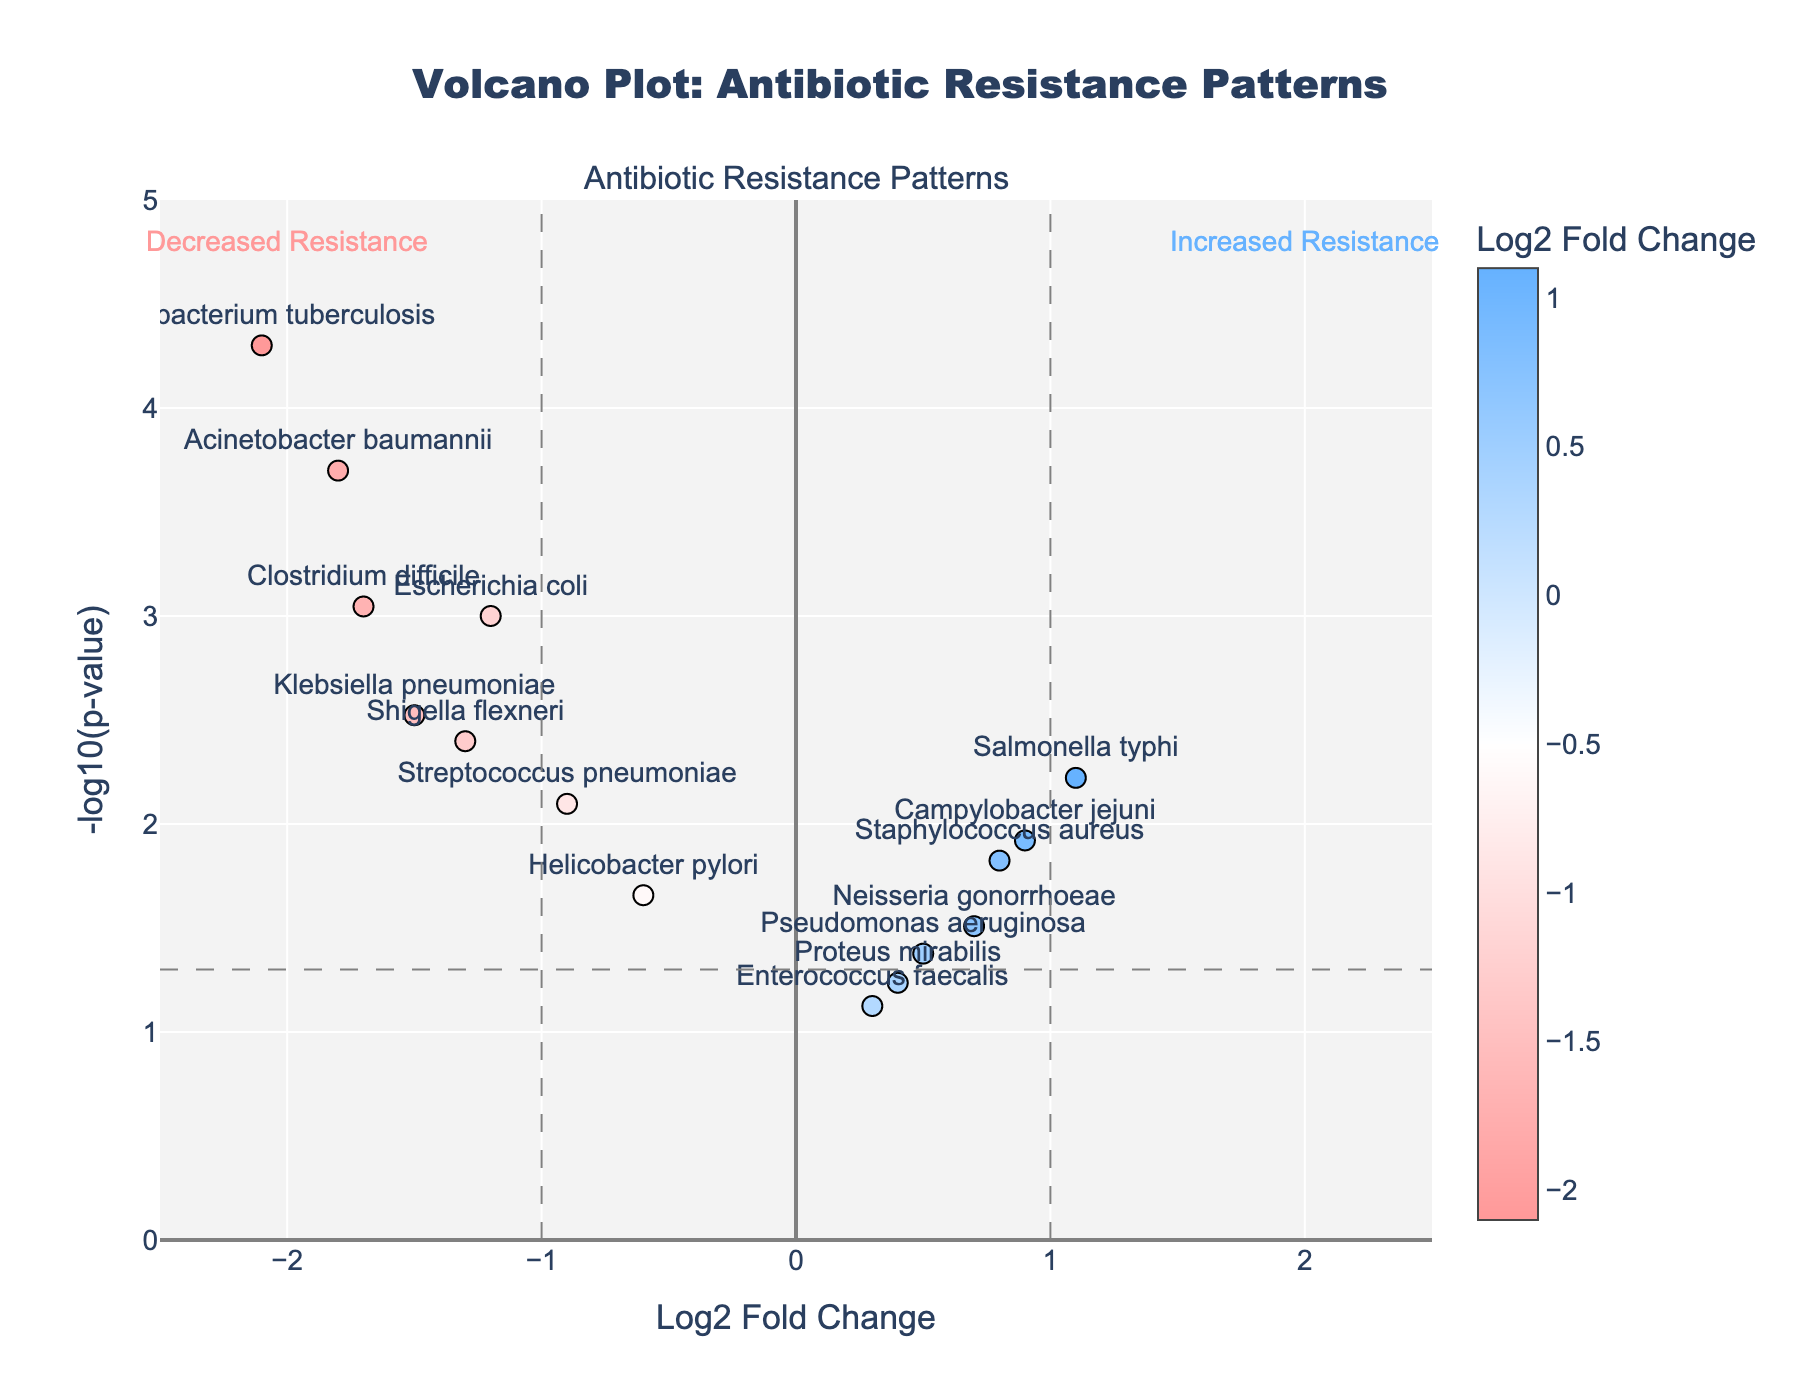What's the title of the plot? The title of the plot is displayed at the top, approximately centered. It reads "Volcano Plot: Antibiotic Resistance Patterns".
Answer: Volcano Plot: Antibiotic Resistance Patterns What does the x-axis represent? The x-axis label appears near the bottom center of the plot. It shows "Log2 Fold Change", indicating the change in resistance levels as a log base 2 fold change.
Answer: Log2 Fold Change Which bacteria has the highest -log10(p-value) and what is its value? By looking for the highest point on the y-axis, which indicates -log10(p-value), we can see that Mycobacterium tuberculosis reaches the highest point. Its value is just above 4.3.
Answer: Mycobacterium tuberculosis, ~4.3 How many bacteria have increased resistance? Increased resistance is indicated by a positive Log2 Fold Change on the right side of the y-axis. By counting the points on this side, we observe five bacteria (Staphylococcus aureus, Salmonella typhi, Neisseria gonorrhoeae, Campylobacter jejuni, and Proteus mirabilis).
Answer: 5 Which bacteria has the most significant decrease in resistance? To find the most significant decrease in resistance, we need to find the lowest Log2 Fold Change furthest to the left. Acinetobacter baumannii has the most negative Log2 Fold Change value reflected at -1.8.
Answer: Acinetobacter baumannii Are there any bacteria with p-values not below 0.05? We recognize that p-values of 0.05 correspond to a -log10(p-value) of around 1.3. There are bacteria above this threshold, identifiable as Enterococcus faecalis and Proteus mirabilis, which are lower than the threshold line at 1.3.
Answer: Enterococcus faecalis, Proteus mirabilis What is the general trend for bacteria positioned above a -log10(p-value) of 3? Observing the positions, those above a -log10(p-value) of 3 have notable Log2 Fold Changes either positively or negatively, indicating significant changes in resistance. The bacteria include Mycobacterium tuberculosis, Acinetobacter baumannii, and Clostridium difficile.
Answer: Significant changes in resistance Which bacteria shows the smallest increase in resistance? The smallest increase in resistance is shown by examining the smallest positive Log2 Fold Change. Enterococcus faecalis shows the smallest increase at 0.3.
Answer: Enterococcus faecalis 